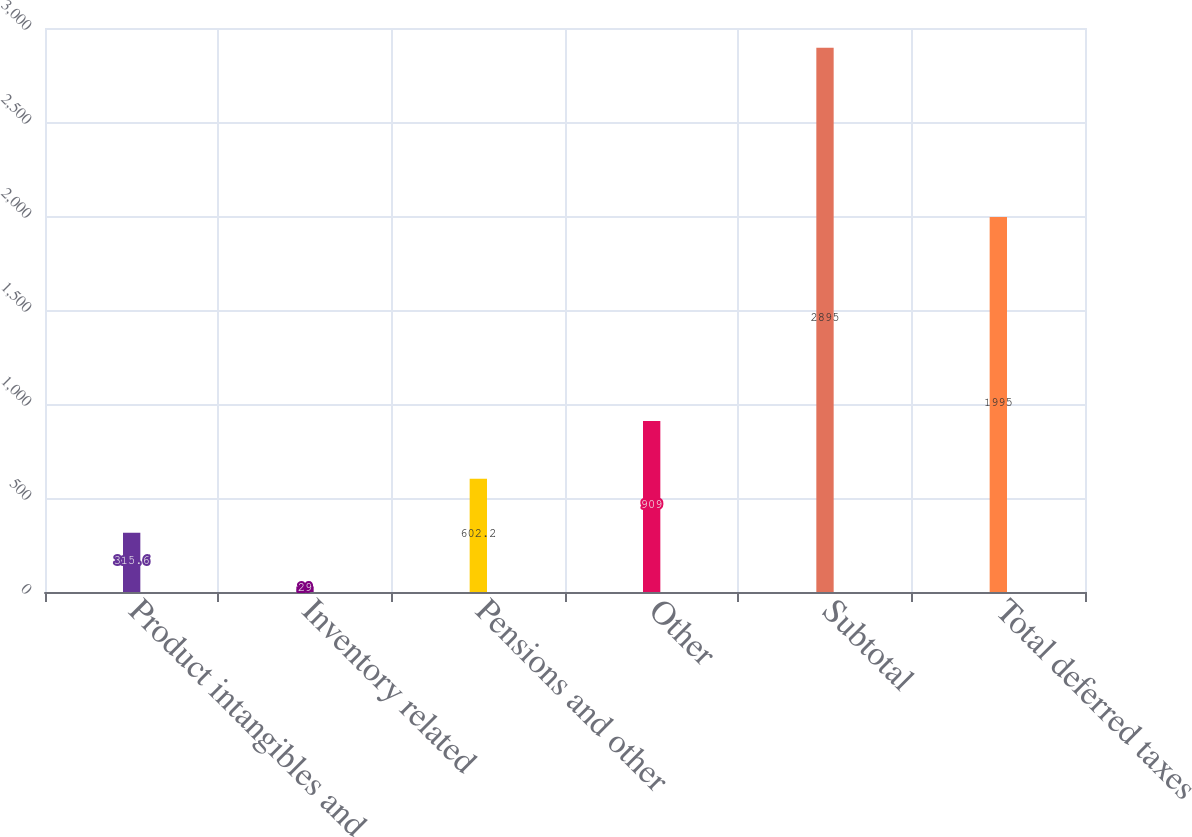Convert chart. <chart><loc_0><loc_0><loc_500><loc_500><bar_chart><fcel>Product intangibles and<fcel>Inventory related<fcel>Pensions and other<fcel>Other<fcel>Subtotal<fcel>Total deferred taxes<nl><fcel>315.6<fcel>29<fcel>602.2<fcel>909<fcel>2895<fcel>1995<nl></chart> 